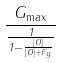<formula> <loc_0><loc_0><loc_500><loc_500>\frac { G _ { \max } } { \frac { 1 } { 1 - \frac { [ O ] } { [ O ] + F _ { g } } } }</formula> 